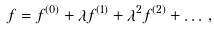Convert formula to latex. <formula><loc_0><loc_0><loc_500><loc_500>f = f ^ { ( 0 ) } + \lambda f ^ { ( 1 ) } + \lambda ^ { 2 } f ^ { ( 2 ) } + \dots \, ,</formula> 